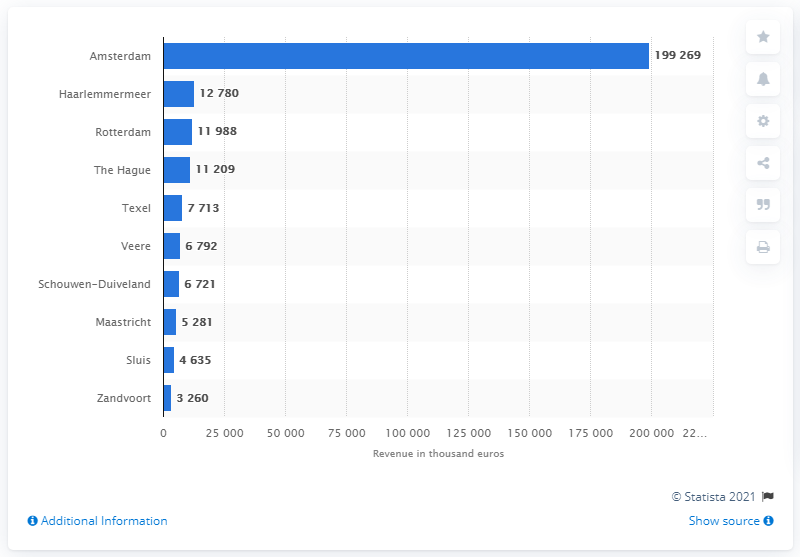Draw attention to some important aspects in this diagram. In 2020, the tourist tax revenue in Amsterdam was 199,269. In 2022, the total tourist tax in Rotterdam was 119,888 euros. 